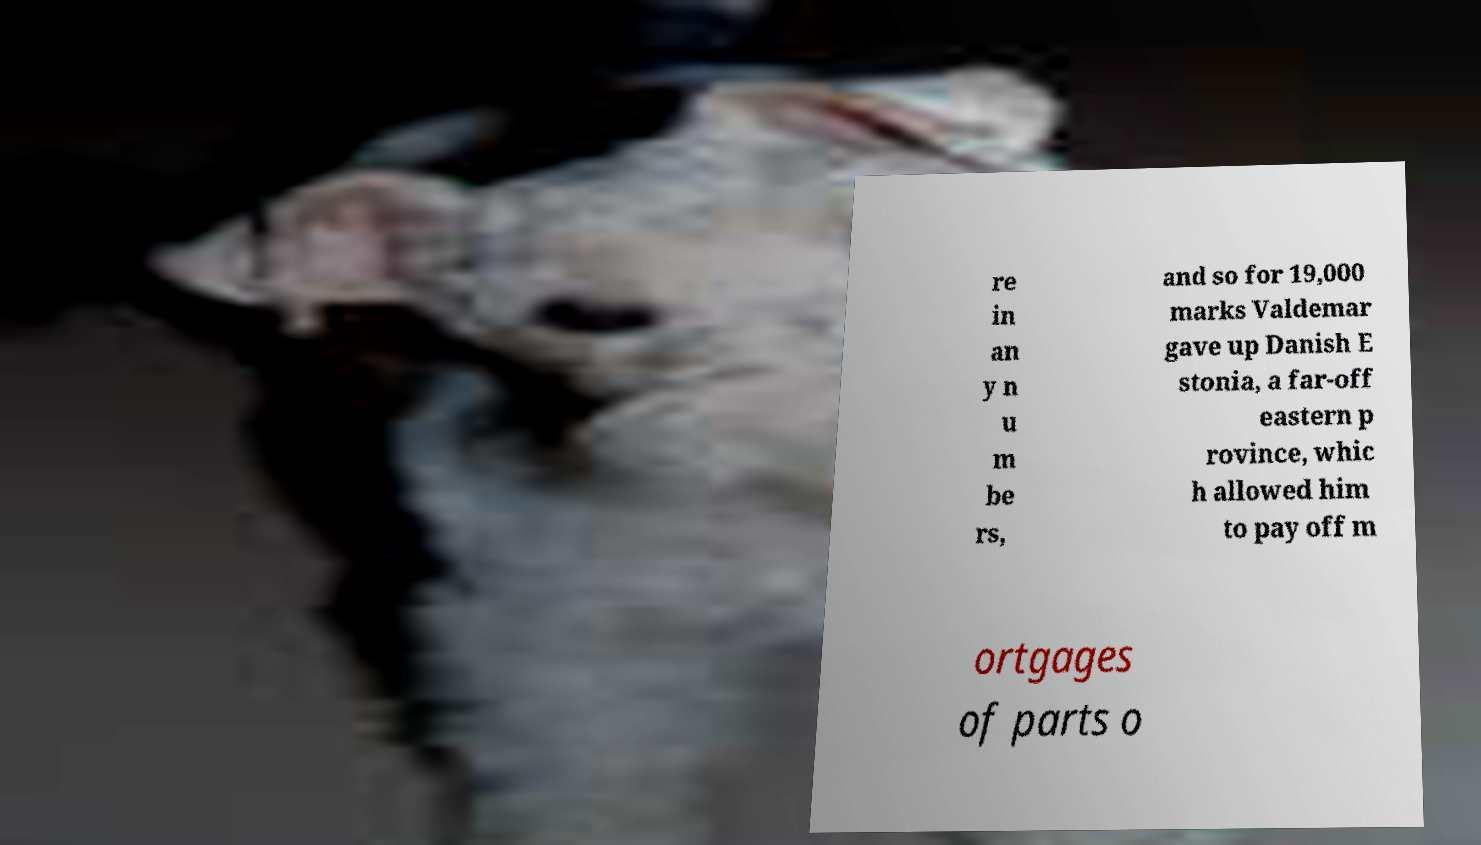I need the written content from this picture converted into text. Can you do that? re in an y n u m be rs, and so for 19,000 marks Valdemar gave up Danish E stonia, a far-off eastern p rovince, whic h allowed him to pay off m ortgages of parts o 